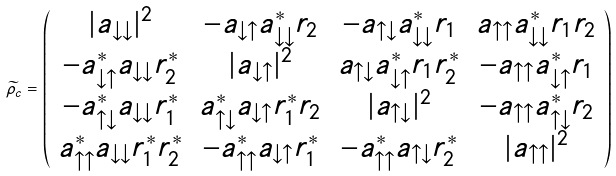<formula> <loc_0><loc_0><loc_500><loc_500>\widetilde { \rho } _ { c } = \left ( \begin{array} { c c c c } | a _ { \downarrow \downarrow } | ^ { 2 } & - a _ { \downarrow \uparrow } a _ { \downarrow \downarrow } ^ { * } r _ { 2 } & - a _ { \uparrow \downarrow } a _ { \downarrow \downarrow } ^ { * } r _ { 1 } & a _ { \uparrow \uparrow } a _ { \downarrow \downarrow } ^ { * } r _ { 1 } r _ { 2 } \\ - a _ { \downarrow \uparrow } ^ { * } a _ { \downarrow \downarrow } r _ { 2 } ^ { * } & | a _ { \downarrow \uparrow } | ^ { 2 } & a _ { \uparrow \downarrow } a _ { \downarrow \uparrow } ^ { * } r _ { 1 } r _ { 2 } ^ { * } & - a _ { \uparrow \uparrow } a _ { \downarrow \uparrow } ^ { * } r _ { 1 } \\ - a _ { \uparrow \downarrow } ^ { * } a _ { \downarrow \downarrow } r _ { 1 } ^ { * } & a _ { \uparrow \downarrow } ^ { * } a _ { \downarrow \uparrow } r _ { 1 } ^ { * } r _ { 2 } & | a _ { \uparrow \downarrow } | ^ { 2 } & - a _ { \uparrow \uparrow } a _ { \uparrow \downarrow } ^ { * } r _ { 2 } \\ a _ { \uparrow \uparrow } ^ { * } a _ { \downarrow \downarrow } r _ { 1 } ^ { * } r _ { 2 } ^ { * } & - a _ { \uparrow \uparrow } ^ { * } a _ { \downarrow \uparrow } r _ { 1 } ^ { * } & - a _ { \uparrow \uparrow } ^ { * } a _ { \uparrow \downarrow } r _ { 2 } ^ { * } & | a _ { \uparrow \uparrow } | ^ { 2 } \\ \end{array} \right )</formula> 